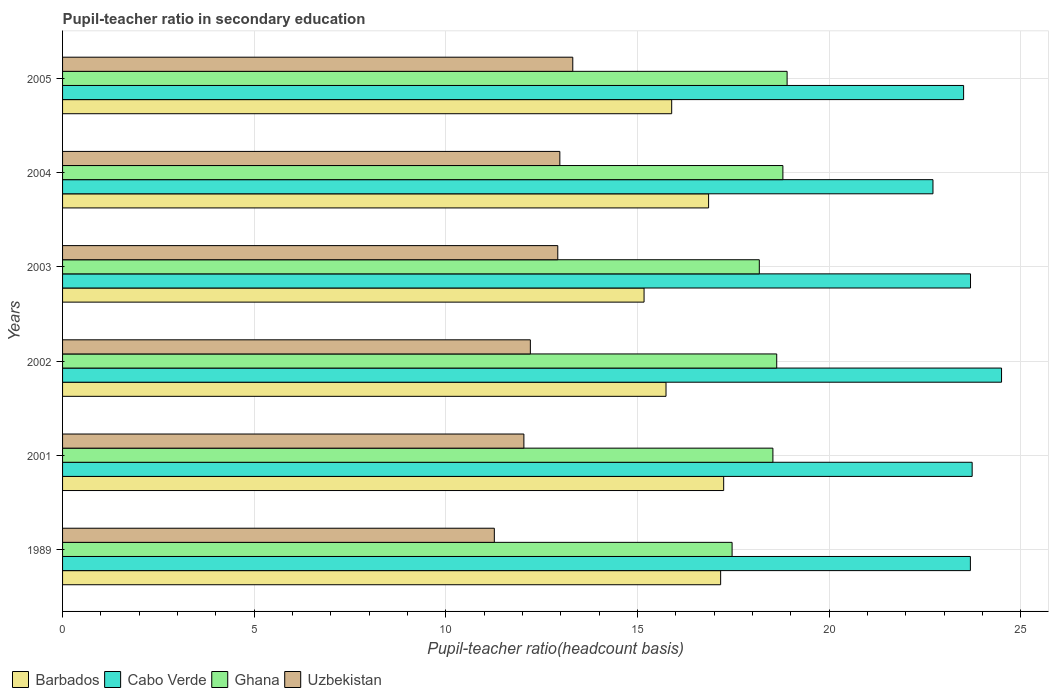Are the number of bars on each tick of the Y-axis equal?
Make the answer very short. Yes. In how many cases, is the number of bars for a given year not equal to the number of legend labels?
Provide a succinct answer. 0. What is the pupil-teacher ratio in secondary education in Uzbekistan in 1989?
Provide a short and direct response. 11.26. Across all years, what is the maximum pupil-teacher ratio in secondary education in Cabo Verde?
Your answer should be very brief. 24.49. Across all years, what is the minimum pupil-teacher ratio in secondary education in Barbados?
Provide a short and direct response. 15.17. In which year was the pupil-teacher ratio in secondary education in Ghana minimum?
Give a very brief answer. 1989. What is the total pupil-teacher ratio in secondary education in Cabo Verde in the graph?
Make the answer very short. 141.79. What is the difference between the pupil-teacher ratio in secondary education in Uzbekistan in 1989 and that in 2002?
Give a very brief answer. -0.94. What is the difference between the pupil-teacher ratio in secondary education in Uzbekistan in 2004 and the pupil-teacher ratio in secondary education in Ghana in 1989?
Keep it short and to the point. -4.49. What is the average pupil-teacher ratio in secondary education in Barbados per year?
Give a very brief answer. 16.34. In the year 2004, what is the difference between the pupil-teacher ratio in secondary education in Uzbekistan and pupil-teacher ratio in secondary education in Ghana?
Make the answer very short. -5.82. In how many years, is the pupil-teacher ratio in secondary education in Uzbekistan greater than 19 ?
Offer a very short reply. 0. What is the ratio of the pupil-teacher ratio in secondary education in Ghana in 1989 to that in 2004?
Provide a succinct answer. 0.93. Is the pupil-teacher ratio in secondary education in Uzbekistan in 2004 less than that in 2005?
Provide a short and direct response. Yes. Is the difference between the pupil-teacher ratio in secondary education in Uzbekistan in 2001 and 2003 greater than the difference between the pupil-teacher ratio in secondary education in Ghana in 2001 and 2003?
Keep it short and to the point. No. What is the difference between the highest and the second highest pupil-teacher ratio in secondary education in Cabo Verde?
Keep it short and to the point. 0.77. What is the difference between the highest and the lowest pupil-teacher ratio in secondary education in Cabo Verde?
Offer a terse response. 1.79. Is it the case that in every year, the sum of the pupil-teacher ratio in secondary education in Ghana and pupil-teacher ratio in secondary education in Cabo Verde is greater than the sum of pupil-teacher ratio in secondary education in Uzbekistan and pupil-teacher ratio in secondary education in Barbados?
Provide a short and direct response. Yes. What does the 1st bar from the bottom in 2002 represents?
Offer a terse response. Barbados. How many bars are there?
Give a very brief answer. 24. Are all the bars in the graph horizontal?
Your answer should be very brief. Yes. How many years are there in the graph?
Provide a short and direct response. 6. Are the values on the major ticks of X-axis written in scientific E-notation?
Ensure brevity in your answer.  No. Where does the legend appear in the graph?
Your answer should be very brief. Bottom left. How many legend labels are there?
Provide a succinct answer. 4. What is the title of the graph?
Provide a short and direct response. Pupil-teacher ratio in secondary education. What is the label or title of the X-axis?
Provide a short and direct response. Pupil-teacher ratio(headcount basis). What is the Pupil-teacher ratio(headcount basis) in Barbados in 1989?
Keep it short and to the point. 17.17. What is the Pupil-teacher ratio(headcount basis) in Cabo Verde in 1989?
Ensure brevity in your answer.  23.68. What is the Pupil-teacher ratio(headcount basis) in Ghana in 1989?
Make the answer very short. 17.46. What is the Pupil-teacher ratio(headcount basis) of Uzbekistan in 1989?
Your response must be concise. 11.26. What is the Pupil-teacher ratio(headcount basis) of Barbados in 2001?
Your answer should be very brief. 17.24. What is the Pupil-teacher ratio(headcount basis) of Cabo Verde in 2001?
Your answer should be very brief. 23.73. What is the Pupil-teacher ratio(headcount basis) in Ghana in 2001?
Provide a short and direct response. 18.53. What is the Pupil-teacher ratio(headcount basis) in Uzbekistan in 2001?
Offer a very short reply. 12.03. What is the Pupil-teacher ratio(headcount basis) of Barbados in 2002?
Your response must be concise. 15.74. What is the Pupil-teacher ratio(headcount basis) of Cabo Verde in 2002?
Provide a short and direct response. 24.49. What is the Pupil-teacher ratio(headcount basis) in Ghana in 2002?
Offer a terse response. 18.63. What is the Pupil-teacher ratio(headcount basis) in Uzbekistan in 2002?
Your response must be concise. 12.2. What is the Pupil-teacher ratio(headcount basis) in Barbados in 2003?
Provide a short and direct response. 15.17. What is the Pupil-teacher ratio(headcount basis) of Cabo Verde in 2003?
Give a very brief answer. 23.68. What is the Pupil-teacher ratio(headcount basis) in Ghana in 2003?
Provide a succinct answer. 18.17. What is the Pupil-teacher ratio(headcount basis) in Uzbekistan in 2003?
Your answer should be compact. 12.92. What is the Pupil-teacher ratio(headcount basis) in Barbados in 2004?
Offer a very short reply. 16.85. What is the Pupil-teacher ratio(headcount basis) of Cabo Verde in 2004?
Your answer should be compact. 22.7. What is the Pupil-teacher ratio(headcount basis) of Ghana in 2004?
Ensure brevity in your answer.  18.79. What is the Pupil-teacher ratio(headcount basis) of Uzbekistan in 2004?
Provide a succinct answer. 12.97. What is the Pupil-teacher ratio(headcount basis) in Barbados in 2005?
Keep it short and to the point. 15.89. What is the Pupil-teacher ratio(headcount basis) in Cabo Verde in 2005?
Offer a terse response. 23.5. What is the Pupil-teacher ratio(headcount basis) of Ghana in 2005?
Your answer should be compact. 18.9. What is the Pupil-teacher ratio(headcount basis) in Uzbekistan in 2005?
Give a very brief answer. 13.31. Across all years, what is the maximum Pupil-teacher ratio(headcount basis) in Barbados?
Provide a succinct answer. 17.24. Across all years, what is the maximum Pupil-teacher ratio(headcount basis) in Cabo Verde?
Your answer should be very brief. 24.49. Across all years, what is the maximum Pupil-teacher ratio(headcount basis) of Ghana?
Offer a terse response. 18.9. Across all years, what is the maximum Pupil-teacher ratio(headcount basis) in Uzbekistan?
Provide a short and direct response. 13.31. Across all years, what is the minimum Pupil-teacher ratio(headcount basis) in Barbados?
Make the answer very short. 15.17. Across all years, what is the minimum Pupil-teacher ratio(headcount basis) in Cabo Verde?
Ensure brevity in your answer.  22.7. Across all years, what is the minimum Pupil-teacher ratio(headcount basis) in Ghana?
Ensure brevity in your answer.  17.46. Across all years, what is the minimum Pupil-teacher ratio(headcount basis) in Uzbekistan?
Offer a very short reply. 11.26. What is the total Pupil-teacher ratio(headcount basis) in Barbados in the graph?
Your response must be concise. 98.06. What is the total Pupil-teacher ratio(headcount basis) in Cabo Verde in the graph?
Ensure brevity in your answer.  141.79. What is the total Pupil-teacher ratio(headcount basis) in Ghana in the graph?
Your answer should be compact. 110.49. What is the total Pupil-teacher ratio(headcount basis) of Uzbekistan in the graph?
Offer a very short reply. 74.7. What is the difference between the Pupil-teacher ratio(headcount basis) of Barbados in 1989 and that in 2001?
Offer a very short reply. -0.08. What is the difference between the Pupil-teacher ratio(headcount basis) of Cabo Verde in 1989 and that in 2001?
Offer a very short reply. -0.05. What is the difference between the Pupil-teacher ratio(headcount basis) in Ghana in 1989 and that in 2001?
Give a very brief answer. -1.06. What is the difference between the Pupil-teacher ratio(headcount basis) of Uzbekistan in 1989 and that in 2001?
Offer a terse response. -0.77. What is the difference between the Pupil-teacher ratio(headcount basis) of Barbados in 1989 and that in 2002?
Keep it short and to the point. 1.42. What is the difference between the Pupil-teacher ratio(headcount basis) in Cabo Verde in 1989 and that in 2002?
Provide a succinct answer. -0.81. What is the difference between the Pupil-teacher ratio(headcount basis) of Ghana in 1989 and that in 2002?
Provide a succinct answer. -1.16. What is the difference between the Pupil-teacher ratio(headcount basis) in Uzbekistan in 1989 and that in 2002?
Give a very brief answer. -0.94. What is the difference between the Pupil-teacher ratio(headcount basis) of Barbados in 1989 and that in 2003?
Your response must be concise. 2. What is the difference between the Pupil-teacher ratio(headcount basis) of Cabo Verde in 1989 and that in 2003?
Your answer should be compact. -0. What is the difference between the Pupil-teacher ratio(headcount basis) of Ghana in 1989 and that in 2003?
Your answer should be compact. -0.71. What is the difference between the Pupil-teacher ratio(headcount basis) of Uzbekistan in 1989 and that in 2003?
Offer a terse response. -1.66. What is the difference between the Pupil-teacher ratio(headcount basis) in Barbados in 1989 and that in 2004?
Your answer should be very brief. 0.31. What is the difference between the Pupil-teacher ratio(headcount basis) in Cabo Verde in 1989 and that in 2004?
Offer a very short reply. 0.98. What is the difference between the Pupil-teacher ratio(headcount basis) of Ghana in 1989 and that in 2004?
Your answer should be very brief. -1.33. What is the difference between the Pupil-teacher ratio(headcount basis) in Uzbekistan in 1989 and that in 2004?
Your response must be concise. -1.71. What is the difference between the Pupil-teacher ratio(headcount basis) of Barbados in 1989 and that in 2005?
Keep it short and to the point. 1.28. What is the difference between the Pupil-teacher ratio(headcount basis) in Cabo Verde in 1989 and that in 2005?
Ensure brevity in your answer.  0.18. What is the difference between the Pupil-teacher ratio(headcount basis) in Ghana in 1989 and that in 2005?
Ensure brevity in your answer.  -1.44. What is the difference between the Pupil-teacher ratio(headcount basis) of Uzbekistan in 1989 and that in 2005?
Your answer should be compact. -2.05. What is the difference between the Pupil-teacher ratio(headcount basis) in Barbados in 2001 and that in 2002?
Offer a terse response. 1.5. What is the difference between the Pupil-teacher ratio(headcount basis) of Cabo Verde in 2001 and that in 2002?
Give a very brief answer. -0.77. What is the difference between the Pupil-teacher ratio(headcount basis) in Ghana in 2001 and that in 2002?
Ensure brevity in your answer.  -0.1. What is the difference between the Pupil-teacher ratio(headcount basis) of Uzbekistan in 2001 and that in 2002?
Provide a short and direct response. -0.17. What is the difference between the Pupil-teacher ratio(headcount basis) of Barbados in 2001 and that in 2003?
Provide a succinct answer. 2.08. What is the difference between the Pupil-teacher ratio(headcount basis) of Cabo Verde in 2001 and that in 2003?
Provide a short and direct response. 0.04. What is the difference between the Pupil-teacher ratio(headcount basis) of Ghana in 2001 and that in 2003?
Offer a very short reply. 0.35. What is the difference between the Pupil-teacher ratio(headcount basis) in Uzbekistan in 2001 and that in 2003?
Offer a very short reply. -0.88. What is the difference between the Pupil-teacher ratio(headcount basis) of Barbados in 2001 and that in 2004?
Offer a terse response. 0.39. What is the difference between the Pupil-teacher ratio(headcount basis) of Cabo Verde in 2001 and that in 2004?
Keep it short and to the point. 1.02. What is the difference between the Pupil-teacher ratio(headcount basis) in Ghana in 2001 and that in 2004?
Keep it short and to the point. -0.26. What is the difference between the Pupil-teacher ratio(headcount basis) of Uzbekistan in 2001 and that in 2004?
Your answer should be very brief. -0.94. What is the difference between the Pupil-teacher ratio(headcount basis) of Barbados in 2001 and that in 2005?
Give a very brief answer. 1.36. What is the difference between the Pupil-teacher ratio(headcount basis) of Cabo Verde in 2001 and that in 2005?
Provide a short and direct response. 0.22. What is the difference between the Pupil-teacher ratio(headcount basis) in Ghana in 2001 and that in 2005?
Your answer should be very brief. -0.37. What is the difference between the Pupil-teacher ratio(headcount basis) of Uzbekistan in 2001 and that in 2005?
Keep it short and to the point. -1.28. What is the difference between the Pupil-teacher ratio(headcount basis) of Barbados in 2002 and that in 2003?
Your answer should be compact. 0.57. What is the difference between the Pupil-teacher ratio(headcount basis) in Cabo Verde in 2002 and that in 2003?
Give a very brief answer. 0.81. What is the difference between the Pupil-teacher ratio(headcount basis) in Ghana in 2002 and that in 2003?
Your answer should be very brief. 0.45. What is the difference between the Pupil-teacher ratio(headcount basis) in Uzbekistan in 2002 and that in 2003?
Offer a terse response. -0.72. What is the difference between the Pupil-teacher ratio(headcount basis) of Barbados in 2002 and that in 2004?
Provide a succinct answer. -1.11. What is the difference between the Pupil-teacher ratio(headcount basis) of Cabo Verde in 2002 and that in 2004?
Your answer should be very brief. 1.79. What is the difference between the Pupil-teacher ratio(headcount basis) of Ghana in 2002 and that in 2004?
Your answer should be compact. -0.16. What is the difference between the Pupil-teacher ratio(headcount basis) of Uzbekistan in 2002 and that in 2004?
Provide a short and direct response. -0.77. What is the difference between the Pupil-teacher ratio(headcount basis) of Barbados in 2002 and that in 2005?
Your answer should be very brief. -0.15. What is the difference between the Pupil-teacher ratio(headcount basis) in Ghana in 2002 and that in 2005?
Provide a succinct answer. -0.27. What is the difference between the Pupil-teacher ratio(headcount basis) in Uzbekistan in 2002 and that in 2005?
Provide a succinct answer. -1.11. What is the difference between the Pupil-teacher ratio(headcount basis) of Barbados in 2003 and that in 2004?
Give a very brief answer. -1.68. What is the difference between the Pupil-teacher ratio(headcount basis) in Cabo Verde in 2003 and that in 2004?
Keep it short and to the point. 0.98. What is the difference between the Pupil-teacher ratio(headcount basis) of Ghana in 2003 and that in 2004?
Offer a very short reply. -0.62. What is the difference between the Pupil-teacher ratio(headcount basis) in Uzbekistan in 2003 and that in 2004?
Make the answer very short. -0.05. What is the difference between the Pupil-teacher ratio(headcount basis) of Barbados in 2003 and that in 2005?
Your answer should be compact. -0.72. What is the difference between the Pupil-teacher ratio(headcount basis) of Cabo Verde in 2003 and that in 2005?
Your answer should be compact. 0.18. What is the difference between the Pupil-teacher ratio(headcount basis) in Ghana in 2003 and that in 2005?
Provide a short and direct response. -0.73. What is the difference between the Pupil-teacher ratio(headcount basis) of Uzbekistan in 2003 and that in 2005?
Your answer should be compact. -0.39. What is the difference between the Pupil-teacher ratio(headcount basis) of Barbados in 2004 and that in 2005?
Offer a very short reply. 0.96. What is the difference between the Pupil-teacher ratio(headcount basis) in Cabo Verde in 2004 and that in 2005?
Offer a terse response. -0.8. What is the difference between the Pupil-teacher ratio(headcount basis) of Ghana in 2004 and that in 2005?
Your answer should be very brief. -0.11. What is the difference between the Pupil-teacher ratio(headcount basis) in Uzbekistan in 2004 and that in 2005?
Provide a short and direct response. -0.34. What is the difference between the Pupil-teacher ratio(headcount basis) in Barbados in 1989 and the Pupil-teacher ratio(headcount basis) in Cabo Verde in 2001?
Provide a succinct answer. -6.56. What is the difference between the Pupil-teacher ratio(headcount basis) in Barbados in 1989 and the Pupil-teacher ratio(headcount basis) in Ghana in 2001?
Give a very brief answer. -1.36. What is the difference between the Pupil-teacher ratio(headcount basis) in Barbados in 1989 and the Pupil-teacher ratio(headcount basis) in Uzbekistan in 2001?
Provide a short and direct response. 5.13. What is the difference between the Pupil-teacher ratio(headcount basis) of Cabo Verde in 1989 and the Pupil-teacher ratio(headcount basis) of Ghana in 2001?
Ensure brevity in your answer.  5.15. What is the difference between the Pupil-teacher ratio(headcount basis) of Cabo Verde in 1989 and the Pupil-teacher ratio(headcount basis) of Uzbekistan in 2001?
Offer a very short reply. 11.65. What is the difference between the Pupil-teacher ratio(headcount basis) of Ghana in 1989 and the Pupil-teacher ratio(headcount basis) of Uzbekistan in 2001?
Give a very brief answer. 5.43. What is the difference between the Pupil-teacher ratio(headcount basis) of Barbados in 1989 and the Pupil-teacher ratio(headcount basis) of Cabo Verde in 2002?
Provide a short and direct response. -7.33. What is the difference between the Pupil-teacher ratio(headcount basis) in Barbados in 1989 and the Pupil-teacher ratio(headcount basis) in Ghana in 2002?
Your response must be concise. -1.46. What is the difference between the Pupil-teacher ratio(headcount basis) in Barbados in 1989 and the Pupil-teacher ratio(headcount basis) in Uzbekistan in 2002?
Your answer should be compact. 4.96. What is the difference between the Pupil-teacher ratio(headcount basis) in Cabo Verde in 1989 and the Pupil-teacher ratio(headcount basis) in Ghana in 2002?
Your response must be concise. 5.05. What is the difference between the Pupil-teacher ratio(headcount basis) in Cabo Verde in 1989 and the Pupil-teacher ratio(headcount basis) in Uzbekistan in 2002?
Make the answer very short. 11.48. What is the difference between the Pupil-teacher ratio(headcount basis) in Ghana in 1989 and the Pupil-teacher ratio(headcount basis) in Uzbekistan in 2002?
Provide a succinct answer. 5.26. What is the difference between the Pupil-teacher ratio(headcount basis) of Barbados in 1989 and the Pupil-teacher ratio(headcount basis) of Cabo Verde in 2003?
Offer a terse response. -6.52. What is the difference between the Pupil-teacher ratio(headcount basis) in Barbados in 1989 and the Pupil-teacher ratio(headcount basis) in Ghana in 2003?
Your answer should be compact. -1.01. What is the difference between the Pupil-teacher ratio(headcount basis) of Barbados in 1989 and the Pupil-teacher ratio(headcount basis) of Uzbekistan in 2003?
Make the answer very short. 4.25. What is the difference between the Pupil-teacher ratio(headcount basis) in Cabo Verde in 1989 and the Pupil-teacher ratio(headcount basis) in Ghana in 2003?
Provide a succinct answer. 5.51. What is the difference between the Pupil-teacher ratio(headcount basis) of Cabo Verde in 1989 and the Pupil-teacher ratio(headcount basis) of Uzbekistan in 2003?
Your answer should be compact. 10.76. What is the difference between the Pupil-teacher ratio(headcount basis) of Ghana in 1989 and the Pupil-teacher ratio(headcount basis) of Uzbekistan in 2003?
Provide a short and direct response. 4.55. What is the difference between the Pupil-teacher ratio(headcount basis) of Barbados in 1989 and the Pupil-teacher ratio(headcount basis) of Cabo Verde in 2004?
Your answer should be very brief. -5.54. What is the difference between the Pupil-teacher ratio(headcount basis) in Barbados in 1989 and the Pupil-teacher ratio(headcount basis) in Ghana in 2004?
Provide a succinct answer. -1.62. What is the difference between the Pupil-teacher ratio(headcount basis) of Barbados in 1989 and the Pupil-teacher ratio(headcount basis) of Uzbekistan in 2004?
Your answer should be very brief. 4.19. What is the difference between the Pupil-teacher ratio(headcount basis) in Cabo Verde in 1989 and the Pupil-teacher ratio(headcount basis) in Ghana in 2004?
Your answer should be compact. 4.89. What is the difference between the Pupil-teacher ratio(headcount basis) of Cabo Verde in 1989 and the Pupil-teacher ratio(headcount basis) of Uzbekistan in 2004?
Make the answer very short. 10.71. What is the difference between the Pupil-teacher ratio(headcount basis) in Ghana in 1989 and the Pupil-teacher ratio(headcount basis) in Uzbekistan in 2004?
Offer a very short reply. 4.49. What is the difference between the Pupil-teacher ratio(headcount basis) of Barbados in 1989 and the Pupil-teacher ratio(headcount basis) of Cabo Verde in 2005?
Give a very brief answer. -6.34. What is the difference between the Pupil-teacher ratio(headcount basis) in Barbados in 1989 and the Pupil-teacher ratio(headcount basis) in Ghana in 2005?
Offer a very short reply. -1.73. What is the difference between the Pupil-teacher ratio(headcount basis) in Barbados in 1989 and the Pupil-teacher ratio(headcount basis) in Uzbekistan in 2005?
Make the answer very short. 3.86. What is the difference between the Pupil-teacher ratio(headcount basis) of Cabo Verde in 1989 and the Pupil-teacher ratio(headcount basis) of Ghana in 2005?
Your answer should be very brief. 4.78. What is the difference between the Pupil-teacher ratio(headcount basis) of Cabo Verde in 1989 and the Pupil-teacher ratio(headcount basis) of Uzbekistan in 2005?
Ensure brevity in your answer.  10.37. What is the difference between the Pupil-teacher ratio(headcount basis) in Ghana in 1989 and the Pupil-teacher ratio(headcount basis) in Uzbekistan in 2005?
Provide a short and direct response. 4.16. What is the difference between the Pupil-teacher ratio(headcount basis) in Barbados in 2001 and the Pupil-teacher ratio(headcount basis) in Cabo Verde in 2002?
Offer a terse response. -7.25. What is the difference between the Pupil-teacher ratio(headcount basis) in Barbados in 2001 and the Pupil-teacher ratio(headcount basis) in Ghana in 2002?
Your answer should be very brief. -1.38. What is the difference between the Pupil-teacher ratio(headcount basis) in Barbados in 2001 and the Pupil-teacher ratio(headcount basis) in Uzbekistan in 2002?
Your response must be concise. 5.04. What is the difference between the Pupil-teacher ratio(headcount basis) in Cabo Verde in 2001 and the Pupil-teacher ratio(headcount basis) in Ghana in 2002?
Offer a very short reply. 5.1. What is the difference between the Pupil-teacher ratio(headcount basis) in Cabo Verde in 2001 and the Pupil-teacher ratio(headcount basis) in Uzbekistan in 2002?
Provide a succinct answer. 11.52. What is the difference between the Pupil-teacher ratio(headcount basis) of Ghana in 2001 and the Pupil-teacher ratio(headcount basis) of Uzbekistan in 2002?
Offer a very short reply. 6.33. What is the difference between the Pupil-teacher ratio(headcount basis) of Barbados in 2001 and the Pupil-teacher ratio(headcount basis) of Cabo Verde in 2003?
Keep it short and to the point. -6.44. What is the difference between the Pupil-teacher ratio(headcount basis) in Barbados in 2001 and the Pupil-teacher ratio(headcount basis) in Ghana in 2003?
Your answer should be very brief. -0.93. What is the difference between the Pupil-teacher ratio(headcount basis) of Barbados in 2001 and the Pupil-teacher ratio(headcount basis) of Uzbekistan in 2003?
Offer a very short reply. 4.33. What is the difference between the Pupil-teacher ratio(headcount basis) of Cabo Verde in 2001 and the Pupil-teacher ratio(headcount basis) of Ghana in 2003?
Provide a succinct answer. 5.55. What is the difference between the Pupil-teacher ratio(headcount basis) of Cabo Verde in 2001 and the Pupil-teacher ratio(headcount basis) of Uzbekistan in 2003?
Ensure brevity in your answer.  10.81. What is the difference between the Pupil-teacher ratio(headcount basis) of Ghana in 2001 and the Pupil-teacher ratio(headcount basis) of Uzbekistan in 2003?
Offer a terse response. 5.61. What is the difference between the Pupil-teacher ratio(headcount basis) of Barbados in 2001 and the Pupil-teacher ratio(headcount basis) of Cabo Verde in 2004?
Your response must be concise. -5.46. What is the difference between the Pupil-teacher ratio(headcount basis) in Barbados in 2001 and the Pupil-teacher ratio(headcount basis) in Ghana in 2004?
Ensure brevity in your answer.  -1.54. What is the difference between the Pupil-teacher ratio(headcount basis) of Barbados in 2001 and the Pupil-teacher ratio(headcount basis) of Uzbekistan in 2004?
Provide a short and direct response. 4.27. What is the difference between the Pupil-teacher ratio(headcount basis) of Cabo Verde in 2001 and the Pupil-teacher ratio(headcount basis) of Ghana in 2004?
Give a very brief answer. 4.94. What is the difference between the Pupil-teacher ratio(headcount basis) of Cabo Verde in 2001 and the Pupil-teacher ratio(headcount basis) of Uzbekistan in 2004?
Provide a short and direct response. 10.76. What is the difference between the Pupil-teacher ratio(headcount basis) in Ghana in 2001 and the Pupil-teacher ratio(headcount basis) in Uzbekistan in 2004?
Keep it short and to the point. 5.56. What is the difference between the Pupil-teacher ratio(headcount basis) in Barbados in 2001 and the Pupil-teacher ratio(headcount basis) in Cabo Verde in 2005?
Offer a terse response. -6.26. What is the difference between the Pupil-teacher ratio(headcount basis) of Barbados in 2001 and the Pupil-teacher ratio(headcount basis) of Ghana in 2005?
Offer a terse response. -1.66. What is the difference between the Pupil-teacher ratio(headcount basis) of Barbados in 2001 and the Pupil-teacher ratio(headcount basis) of Uzbekistan in 2005?
Give a very brief answer. 3.94. What is the difference between the Pupil-teacher ratio(headcount basis) in Cabo Verde in 2001 and the Pupil-teacher ratio(headcount basis) in Ghana in 2005?
Your answer should be very brief. 4.83. What is the difference between the Pupil-teacher ratio(headcount basis) in Cabo Verde in 2001 and the Pupil-teacher ratio(headcount basis) in Uzbekistan in 2005?
Keep it short and to the point. 10.42. What is the difference between the Pupil-teacher ratio(headcount basis) in Ghana in 2001 and the Pupil-teacher ratio(headcount basis) in Uzbekistan in 2005?
Your answer should be very brief. 5.22. What is the difference between the Pupil-teacher ratio(headcount basis) of Barbados in 2002 and the Pupil-teacher ratio(headcount basis) of Cabo Verde in 2003?
Ensure brevity in your answer.  -7.94. What is the difference between the Pupil-teacher ratio(headcount basis) of Barbados in 2002 and the Pupil-teacher ratio(headcount basis) of Ghana in 2003?
Give a very brief answer. -2.43. What is the difference between the Pupil-teacher ratio(headcount basis) of Barbados in 2002 and the Pupil-teacher ratio(headcount basis) of Uzbekistan in 2003?
Provide a succinct answer. 2.82. What is the difference between the Pupil-teacher ratio(headcount basis) in Cabo Verde in 2002 and the Pupil-teacher ratio(headcount basis) in Ghana in 2003?
Offer a very short reply. 6.32. What is the difference between the Pupil-teacher ratio(headcount basis) in Cabo Verde in 2002 and the Pupil-teacher ratio(headcount basis) in Uzbekistan in 2003?
Ensure brevity in your answer.  11.58. What is the difference between the Pupil-teacher ratio(headcount basis) in Ghana in 2002 and the Pupil-teacher ratio(headcount basis) in Uzbekistan in 2003?
Your answer should be very brief. 5.71. What is the difference between the Pupil-teacher ratio(headcount basis) of Barbados in 2002 and the Pupil-teacher ratio(headcount basis) of Cabo Verde in 2004?
Provide a succinct answer. -6.96. What is the difference between the Pupil-teacher ratio(headcount basis) of Barbados in 2002 and the Pupil-teacher ratio(headcount basis) of Ghana in 2004?
Offer a very short reply. -3.05. What is the difference between the Pupil-teacher ratio(headcount basis) of Barbados in 2002 and the Pupil-teacher ratio(headcount basis) of Uzbekistan in 2004?
Ensure brevity in your answer.  2.77. What is the difference between the Pupil-teacher ratio(headcount basis) of Cabo Verde in 2002 and the Pupil-teacher ratio(headcount basis) of Ghana in 2004?
Give a very brief answer. 5.7. What is the difference between the Pupil-teacher ratio(headcount basis) of Cabo Verde in 2002 and the Pupil-teacher ratio(headcount basis) of Uzbekistan in 2004?
Provide a succinct answer. 11.52. What is the difference between the Pupil-teacher ratio(headcount basis) in Ghana in 2002 and the Pupil-teacher ratio(headcount basis) in Uzbekistan in 2004?
Keep it short and to the point. 5.66. What is the difference between the Pupil-teacher ratio(headcount basis) in Barbados in 2002 and the Pupil-teacher ratio(headcount basis) in Cabo Verde in 2005?
Ensure brevity in your answer.  -7.76. What is the difference between the Pupil-teacher ratio(headcount basis) in Barbados in 2002 and the Pupil-teacher ratio(headcount basis) in Ghana in 2005?
Keep it short and to the point. -3.16. What is the difference between the Pupil-teacher ratio(headcount basis) of Barbados in 2002 and the Pupil-teacher ratio(headcount basis) of Uzbekistan in 2005?
Your answer should be compact. 2.43. What is the difference between the Pupil-teacher ratio(headcount basis) of Cabo Verde in 2002 and the Pupil-teacher ratio(headcount basis) of Ghana in 2005?
Your answer should be compact. 5.59. What is the difference between the Pupil-teacher ratio(headcount basis) in Cabo Verde in 2002 and the Pupil-teacher ratio(headcount basis) in Uzbekistan in 2005?
Make the answer very short. 11.18. What is the difference between the Pupil-teacher ratio(headcount basis) in Ghana in 2002 and the Pupil-teacher ratio(headcount basis) in Uzbekistan in 2005?
Your answer should be very brief. 5.32. What is the difference between the Pupil-teacher ratio(headcount basis) in Barbados in 2003 and the Pupil-teacher ratio(headcount basis) in Cabo Verde in 2004?
Provide a short and direct response. -7.54. What is the difference between the Pupil-teacher ratio(headcount basis) of Barbados in 2003 and the Pupil-teacher ratio(headcount basis) of Ghana in 2004?
Offer a very short reply. -3.62. What is the difference between the Pupil-teacher ratio(headcount basis) of Barbados in 2003 and the Pupil-teacher ratio(headcount basis) of Uzbekistan in 2004?
Offer a very short reply. 2.2. What is the difference between the Pupil-teacher ratio(headcount basis) of Cabo Verde in 2003 and the Pupil-teacher ratio(headcount basis) of Ghana in 2004?
Give a very brief answer. 4.89. What is the difference between the Pupil-teacher ratio(headcount basis) in Cabo Verde in 2003 and the Pupil-teacher ratio(headcount basis) in Uzbekistan in 2004?
Keep it short and to the point. 10.71. What is the difference between the Pupil-teacher ratio(headcount basis) of Ghana in 2003 and the Pupil-teacher ratio(headcount basis) of Uzbekistan in 2004?
Provide a succinct answer. 5.2. What is the difference between the Pupil-teacher ratio(headcount basis) in Barbados in 2003 and the Pupil-teacher ratio(headcount basis) in Cabo Verde in 2005?
Offer a terse response. -8.34. What is the difference between the Pupil-teacher ratio(headcount basis) in Barbados in 2003 and the Pupil-teacher ratio(headcount basis) in Ghana in 2005?
Make the answer very short. -3.73. What is the difference between the Pupil-teacher ratio(headcount basis) in Barbados in 2003 and the Pupil-teacher ratio(headcount basis) in Uzbekistan in 2005?
Offer a terse response. 1.86. What is the difference between the Pupil-teacher ratio(headcount basis) in Cabo Verde in 2003 and the Pupil-teacher ratio(headcount basis) in Ghana in 2005?
Your response must be concise. 4.78. What is the difference between the Pupil-teacher ratio(headcount basis) of Cabo Verde in 2003 and the Pupil-teacher ratio(headcount basis) of Uzbekistan in 2005?
Your answer should be compact. 10.37. What is the difference between the Pupil-teacher ratio(headcount basis) in Ghana in 2003 and the Pupil-teacher ratio(headcount basis) in Uzbekistan in 2005?
Your response must be concise. 4.87. What is the difference between the Pupil-teacher ratio(headcount basis) of Barbados in 2004 and the Pupil-teacher ratio(headcount basis) of Cabo Verde in 2005?
Offer a very short reply. -6.65. What is the difference between the Pupil-teacher ratio(headcount basis) in Barbados in 2004 and the Pupil-teacher ratio(headcount basis) in Ghana in 2005?
Provide a short and direct response. -2.05. What is the difference between the Pupil-teacher ratio(headcount basis) of Barbados in 2004 and the Pupil-teacher ratio(headcount basis) of Uzbekistan in 2005?
Provide a succinct answer. 3.54. What is the difference between the Pupil-teacher ratio(headcount basis) of Cabo Verde in 2004 and the Pupil-teacher ratio(headcount basis) of Ghana in 2005?
Keep it short and to the point. 3.8. What is the difference between the Pupil-teacher ratio(headcount basis) of Cabo Verde in 2004 and the Pupil-teacher ratio(headcount basis) of Uzbekistan in 2005?
Keep it short and to the point. 9.4. What is the difference between the Pupil-teacher ratio(headcount basis) in Ghana in 2004 and the Pupil-teacher ratio(headcount basis) in Uzbekistan in 2005?
Offer a terse response. 5.48. What is the average Pupil-teacher ratio(headcount basis) in Barbados per year?
Provide a short and direct response. 16.34. What is the average Pupil-teacher ratio(headcount basis) in Cabo Verde per year?
Ensure brevity in your answer.  23.63. What is the average Pupil-teacher ratio(headcount basis) of Ghana per year?
Give a very brief answer. 18.41. What is the average Pupil-teacher ratio(headcount basis) in Uzbekistan per year?
Offer a very short reply. 12.45. In the year 1989, what is the difference between the Pupil-teacher ratio(headcount basis) of Barbados and Pupil-teacher ratio(headcount basis) of Cabo Verde?
Provide a short and direct response. -6.51. In the year 1989, what is the difference between the Pupil-teacher ratio(headcount basis) in Barbados and Pupil-teacher ratio(headcount basis) in Ghana?
Provide a succinct answer. -0.3. In the year 1989, what is the difference between the Pupil-teacher ratio(headcount basis) in Barbados and Pupil-teacher ratio(headcount basis) in Uzbekistan?
Keep it short and to the point. 5.9. In the year 1989, what is the difference between the Pupil-teacher ratio(headcount basis) of Cabo Verde and Pupil-teacher ratio(headcount basis) of Ghana?
Keep it short and to the point. 6.22. In the year 1989, what is the difference between the Pupil-teacher ratio(headcount basis) in Cabo Verde and Pupil-teacher ratio(headcount basis) in Uzbekistan?
Provide a short and direct response. 12.42. In the year 1989, what is the difference between the Pupil-teacher ratio(headcount basis) in Ghana and Pupil-teacher ratio(headcount basis) in Uzbekistan?
Provide a succinct answer. 6.2. In the year 2001, what is the difference between the Pupil-teacher ratio(headcount basis) of Barbados and Pupil-teacher ratio(headcount basis) of Cabo Verde?
Your answer should be compact. -6.48. In the year 2001, what is the difference between the Pupil-teacher ratio(headcount basis) in Barbados and Pupil-teacher ratio(headcount basis) in Ghana?
Provide a succinct answer. -1.28. In the year 2001, what is the difference between the Pupil-teacher ratio(headcount basis) of Barbados and Pupil-teacher ratio(headcount basis) of Uzbekistan?
Provide a short and direct response. 5.21. In the year 2001, what is the difference between the Pupil-teacher ratio(headcount basis) in Cabo Verde and Pupil-teacher ratio(headcount basis) in Ghana?
Your answer should be very brief. 5.2. In the year 2001, what is the difference between the Pupil-teacher ratio(headcount basis) of Cabo Verde and Pupil-teacher ratio(headcount basis) of Uzbekistan?
Provide a short and direct response. 11.69. In the year 2001, what is the difference between the Pupil-teacher ratio(headcount basis) in Ghana and Pupil-teacher ratio(headcount basis) in Uzbekistan?
Offer a terse response. 6.5. In the year 2002, what is the difference between the Pupil-teacher ratio(headcount basis) in Barbados and Pupil-teacher ratio(headcount basis) in Cabo Verde?
Keep it short and to the point. -8.75. In the year 2002, what is the difference between the Pupil-teacher ratio(headcount basis) in Barbados and Pupil-teacher ratio(headcount basis) in Ghana?
Provide a short and direct response. -2.89. In the year 2002, what is the difference between the Pupil-teacher ratio(headcount basis) of Barbados and Pupil-teacher ratio(headcount basis) of Uzbekistan?
Ensure brevity in your answer.  3.54. In the year 2002, what is the difference between the Pupil-teacher ratio(headcount basis) in Cabo Verde and Pupil-teacher ratio(headcount basis) in Ghana?
Provide a succinct answer. 5.86. In the year 2002, what is the difference between the Pupil-teacher ratio(headcount basis) of Cabo Verde and Pupil-teacher ratio(headcount basis) of Uzbekistan?
Give a very brief answer. 12.29. In the year 2002, what is the difference between the Pupil-teacher ratio(headcount basis) of Ghana and Pupil-teacher ratio(headcount basis) of Uzbekistan?
Offer a terse response. 6.43. In the year 2003, what is the difference between the Pupil-teacher ratio(headcount basis) in Barbados and Pupil-teacher ratio(headcount basis) in Cabo Verde?
Your answer should be very brief. -8.52. In the year 2003, what is the difference between the Pupil-teacher ratio(headcount basis) of Barbados and Pupil-teacher ratio(headcount basis) of Ghana?
Your answer should be compact. -3.01. In the year 2003, what is the difference between the Pupil-teacher ratio(headcount basis) in Barbados and Pupil-teacher ratio(headcount basis) in Uzbekistan?
Offer a terse response. 2.25. In the year 2003, what is the difference between the Pupil-teacher ratio(headcount basis) of Cabo Verde and Pupil-teacher ratio(headcount basis) of Ghana?
Keep it short and to the point. 5.51. In the year 2003, what is the difference between the Pupil-teacher ratio(headcount basis) of Cabo Verde and Pupil-teacher ratio(headcount basis) of Uzbekistan?
Provide a succinct answer. 10.77. In the year 2003, what is the difference between the Pupil-teacher ratio(headcount basis) in Ghana and Pupil-teacher ratio(headcount basis) in Uzbekistan?
Give a very brief answer. 5.26. In the year 2004, what is the difference between the Pupil-teacher ratio(headcount basis) of Barbados and Pupil-teacher ratio(headcount basis) of Cabo Verde?
Give a very brief answer. -5.85. In the year 2004, what is the difference between the Pupil-teacher ratio(headcount basis) of Barbados and Pupil-teacher ratio(headcount basis) of Ghana?
Offer a very short reply. -1.94. In the year 2004, what is the difference between the Pupil-teacher ratio(headcount basis) in Barbados and Pupil-teacher ratio(headcount basis) in Uzbekistan?
Provide a succinct answer. 3.88. In the year 2004, what is the difference between the Pupil-teacher ratio(headcount basis) in Cabo Verde and Pupil-teacher ratio(headcount basis) in Ghana?
Provide a short and direct response. 3.91. In the year 2004, what is the difference between the Pupil-teacher ratio(headcount basis) in Cabo Verde and Pupil-teacher ratio(headcount basis) in Uzbekistan?
Provide a succinct answer. 9.73. In the year 2004, what is the difference between the Pupil-teacher ratio(headcount basis) of Ghana and Pupil-teacher ratio(headcount basis) of Uzbekistan?
Your response must be concise. 5.82. In the year 2005, what is the difference between the Pupil-teacher ratio(headcount basis) in Barbados and Pupil-teacher ratio(headcount basis) in Cabo Verde?
Your answer should be very brief. -7.61. In the year 2005, what is the difference between the Pupil-teacher ratio(headcount basis) in Barbados and Pupil-teacher ratio(headcount basis) in Ghana?
Give a very brief answer. -3.01. In the year 2005, what is the difference between the Pupil-teacher ratio(headcount basis) in Barbados and Pupil-teacher ratio(headcount basis) in Uzbekistan?
Offer a terse response. 2.58. In the year 2005, what is the difference between the Pupil-teacher ratio(headcount basis) of Cabo Verde and Pupil-teacher ratio(headcount basis) of Ghana?
Provide a succinct answer. 4.6. In the year 2005, what is the difference between the Pupil-teacher ratio(headcount basis) in Cabo Verde and Pupil-teacher ratio(headcount basis) in Uzbekistan?
Your answer should be compact. 10.19. In the year 2005, what is the difference between the Pupil-teacher ratio(headcount basis) of Ghana and Pupil-teacher ratio(headcount basis) of Uzbekistan?
Your answer should be very brief. 5.59. What is the ratio of the Pupil-teacher ratio(headcount basis) in Barbados in 1989 to that in 2001?
Provide a short and direct response. 1. What is the ratio of the Pupil-teacher ratio(headcount basis) of Cabo Verde in 1989 to that in 2001?
Keep it short and to the point. 1. What is the ratio of the Pupil-teacher ratio(headcount basis) of Ghana in 1989 to that in 2001?
Give a very brief answer. 0.94. What is the ratio of the Pupil-teacher ratio(headcount basis) in Uzbekistan in 1989 to that in 2001?
Offer a terse response. 0.94. What is the ratio of the Pupil-teacher ratio(headcount basis) in Barbados in 1989 to that in 2002?
Keep it short and to the point. 1.09. What is the ratio of the Pupil-teacher ratio(headcount basis) of Cabo Verde in 1989 to that in 2002?
Ensure brevity in your answer.  0.97. What is the ratio of the Pupil-teacher ratio(headcount basis) in Uzbekistan in 1989 to that in 2002?
Offer a terse response. 0.92. What is the ratio of the Pupil-teacher ratio(headcount basis) of Barbados in 1989 to that in 2003?
Your answer should be compact. 1.13. What is the ratio of the Pupil-teacher ratio(headcount basis) of Cabo Verde in 1989 to that in 2003?
Provide a short and direct response. 1. What is the ratio of the Pupil-teacher ratio(headcount basis) in Ghana in 1989 to that in 2003?
Your answer should be compact. 0.96. What is the ratio of the Pupil-teacher ratio(headcount basis) in Uzbekistan in 1989 to that in 2003?
Ensure brevity in your answer.  0.87. What is the ratio of the Pupil-teacher ratio(headcount basis) in Barbados in 1989 to that in 2004?
Offer a very short reply. 1.02. What is the ratio of the Pupil-teacher ratio(headcount basis) of Cabo Verde in 1989 to that in 2004?
Provide a short and direct response. 1.04. What is the ratio of the Pupil-teacher ratio(headcount basis) in Ghana in 1989 to that in 2004?
Make the answer very short. 0.93. What is the ratio of the Pupil-teacher ratio(headcount basis) in Uzbekistan in 1989 to that in 2004?
Your answer should be compact. 0.87. What is the ratio of the Pupil-teacher ratio(headcount basis) in Barbados in 1989 to that in 2005?
Ensure brevity in your answer.  1.08. What is the ratio of the Pupil-teacher ratio(headcount basis) of Cabo Verde in 1989 to that in 2005?
Ensure brevity in your answer.  1.01. What is the ratio of the Pupil-teacher ratio(headcount basis) in Ghana in 1989 to that in 2005?
Your response must be concise. 0.92. What is the ratio of the Pupil-teacher ratio(headcount basis) in Uzbekistan in 1989 to that in 2005?
Your response must be concise. 0.85. What is the ratio of the Pupil-teacher ratio(headcount basis) of Barbados in 2001 to that in 2002?
Offer a terse response. 1.1. What is the ratio of the Pupil-teacher ratio(headcount basis) of Cabo Verde in 2001 to that in 2002?
Your answer should be compact. 0.97. What is the ratio of the Pupil-teacher ratio(headcount basis) of Ghana in 2001 to that in 2002?
Ensure brevity in your answer.  0.99. What is the ratio of the Pupil-teacher ratio(headcount basis) in Uzbekistan in 2001 to that in 2002?
Provide a short and direct response. 0.99. What is the ratio of the Pupil-teacher ratio(headcount basis) in Barbados in 2001 to that in 2003?
Provide a succinct answer. 1.14. What is the ratio of the Pupil-teacher ratio(headcount basis) in Cabo Verde in 2001 to that in 2003?
Offer a terse response. 1. What is the ratio of the Pupil-teacher ratio(headcount basis) of Ghana in 2001 to that in 2003?
Give a very brief answer. 1.02. What is the ratio of the Pupil-teacher ratio(headcount basis) in Uzbekistan in 2001 to that in 2003?
Offer a very short reply. 0.93. What is the ratio of the Pupil-teacher ratio(headcount basis) in Barbados in 2001 to that in 2004?
Provide a succinct answer. 1.02. What is the ratio of the Pupil-teacher ratio(headcount basis) in Cabo Verde in 2001 to that in 2004?
Your answer should be compact. 1.04. What is the ratio of the Pupil-teacher ratio(headcount basis) in Ghana in 2001 to that in 2004?
Your response must be concise. 0.99. What is the ratio of the Pupil-teacher ratio(headcount basis) in Uzbekistan in 2001 to that in 2004?
Provide a succinct answer. 0.93. What is the ratio of the Pupil-teacher ratio(headcount basis) in Barbados in 2001 to that in 2005?
Your response must be concise. 1.09. What is the ratio of the Pupil-teacher ratio(headcount basis) of Cabo Verde in 2001 to that in 2005?
Your response must be concise. 1.01. What is the ratio of the Pupil-teacher ratio(headcount basis) in Ghana in 2001 to that in 2005?
Provide a short and direct response. 0.98. What is the ratio of the Pupil-teacher ratio(headcount basis) of Uzbekistan in 2001 to that in 2005?
Give a very brief answer. 0.9. What is the ratio of the Pupil-teacher ratio(headcount basis) in Barbados in 2002 to that in 2003?
Offer a very short reply. 1.04. What is the ratio of the Pupil-teacher ratio(headcount basis) in Cabo Verde in 2002 to that in 2003?
Your answer should be compact. 1.03. What is the ratio of the Pupil-teacher ratio(headcount basis) of Ghana in 2002 to that in 2003?
Keep it short and to the point. 1.02. What is the ratio of the Pupil-teacher ratio(headcount basis) of Uzbekistan in 2002 to that in 2003?
Give a very brief answer. 0.94. What is the ratio of the Pupil-teacher ratio(headcount basis) of Barbados in 2002 to that in 2004?
Your response must be concise. 0.93. What is the ratio of the Pupil-teacher ratio(headcount basis) of Cabo Verde in 2002 to that in 2004?
Give a very brief answer. 1.08. What is the ratio of the Pupil-teacher ratio(headcount basis) in Uzbekistan in 2002 to that in 2004?
Keep it short and to the point. 0.94. What is the ratio of the Pupil-teacher ratio(headcount basis) in Cabo Verde in 2002 to that in 2005?
Make the answer very short. 1.04. What is the ratio of the Pupil-teacher ratio(headcount basis) in Ghana in 2002 to that in 2005?
Your answer should be compact. 0.99. What is the ratio of the Pupil-teacher ratio(headcount basis) of Uzbekistan in 2002 to that in 2005?
Keep it short and to the point. 0.92. What is the ratio of the Pupil-teacher ratio(headcount basis) in Barbados in 2003 to that in 2004?
Provide a short and direct response. 0.9. What is the ratio of the Pupil-teacher ratio(headcount basis) of Cabo Verde in 2003 to that in 2004?
Provide a succinct answer. 1.04. What is the ratio of the Pupil-teacher ratio(headcount basis) in Ghana in 2003 to that in 2004?
Offer a terse response. 0.97. What is the ratio of the Pupil-teacher ratio(headcount basis) in Barbados in 2003 to that in 2005?
Your answer should be compact. 0.95. What is the ratio of the Pupil-teacher ratio(headcount basis) in Cabo Verde in 2003 to that in 2005?
Give a very brief answer. 1.01. What is the ratio of the Pupil-teacher ratio(headcount basis) in Ghana in 2003 to that in 2005?
Your answer should be compact. 0.96. What is the ratio of the Pupil-teacher ratio(headcount basis) of Uzbekistan in 2003 to that in 2005?
Your answer should be compact. 0.97. What is the ratio of the Pupil-teacher ratio(headcount basis) in Barbados in 2004 to that in 2005?
Provide a succinct answer. 1.06. What is the ratio of the Pupil-teacher ratio(headcount basis) of Cabo Verde in 2004 to that in 2005?
Provide a short and direct response. 0.97. What is the ratio of the Pupil-teacher ratio(headcount basis) in Uzbekistan in 2004 to that in 2005?
Give a very brief answer. 0.97. What is the difference between the highest and the second highest Pupil-teacher ratio(headcount basis) of Barbados?
Make the answer very short. 0.08. What is the difference between the highest and the second highest Pupil-teacher ratio(headcount basis) in Cabo Verde?
Provide a short and direct response. 0.77. What is the difference between the highest and the second highest Pupil-teacher ratio(headcount basis) in Ghana?
Your answer should be very brief. 0.11. What is the difference between the highest and the second highest Pupil-teacher ratio(headcount basis) in Uzbekistan?
Your answer should be compact. 0.34. What is the difference between the highest and the lowest Pupil-teacher ratio(headcount basis) in Barbados?
Keep it short and to the point. 2.08. What is the difference between the highest and the lowest Pupil-teacher ratio(headcount basis) in Cabo Verde?
Your response must be concise. 1.79. What is the difference between the highest and the lowest Pupil-teacher ratio(headcount basis) in Ghana?
Your answer should be compact. 1.44. What is the difference between the highest and the lowest Pupil-teacher ratio(headcount basis) in Uzbekistan?
Your response must be concise. 2.05. 